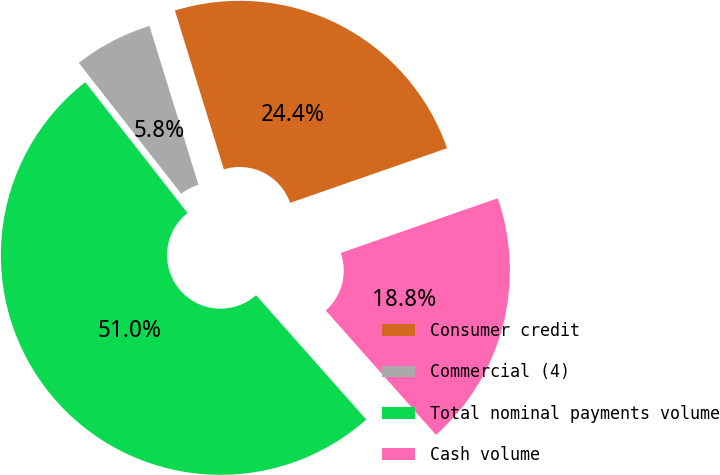Convert chart to OTSL. <chart><loc_0><loc_0><loc_500><loc_500><pie_chart><fcel>Consumer credit<fcel>Commercial (4)<fcel>Total nominal payments volume<fcel>Cash volume<nl><fcel>24.42%<fcel>5.81%<fcel>50.98%<fcel>18.79%<nl></chart> 